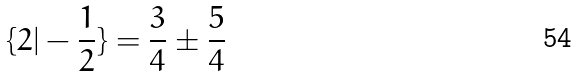<formula> <loc_0><loc_0><loc_500><loc_500>\{ 2 | - \frac { 1 } { 2 } \} = \frac { 3 } { 4 } \pm \frac { 5 } { 4 }</formula> 